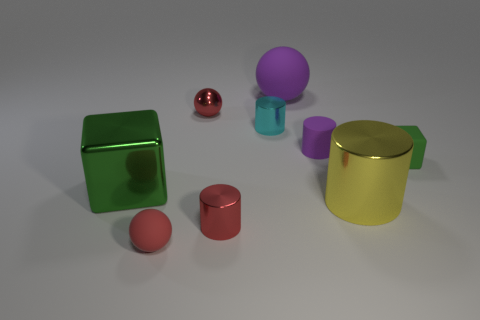There is a large metal object that is to the left of the metallic ball; what is its shape?
Offer a very short reply. Cube. Are there fewer big green metallic objects than tiny gray rubber cylinders?
Make the answer very short. No. Are there any other things that are the same color as the large block?
Make the answer very short. Yes. What is the size of the green cube that is to the right of the cyan metal cylinder?
Ensure brevity in your answer.  Small. Are there more purple matte cylinders than large gray rubber cylinders?
Offer a terse response. Yes. What material is the tiny purple cylinder?
Provide a succinct answer. Rubber. What number of other objects are the same material as the big purple thing?
Keep it short and to the point. 3. How many tiny cyan shiny spheres are there?
Offer a very short reply. 0. What is the material of the purple object that is the same shape as the big yellow metal object?
Your answer should be compact. Rubber. Do the tiny sphere that is in front of the matte block and the big sphere have the same material?
Make the answer very short. Yes. 